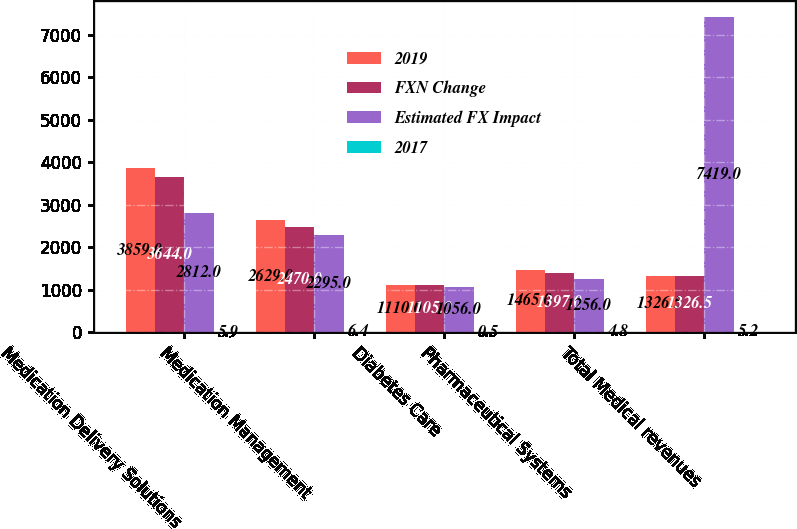Convert chart. <chart><loc_0><loc_0><loc_500><loc_500><stacked_bar_chart><ecel><fcel>Medication Delivery Solutions<fcel>Medication Management<fcel>Diabetes Care<fcel>Pharmaceutical Systems<fcel>Total Medical revenues<nl><fcel>2019<fcel>3859<fcel>2629<fcel>1110<fcel>1465<fcel>1326.5<nl><fcel>FXN Change<fcel>3644<fcel>2470<fcel>1105<fcel>1397<fcel>1326.5<nl><fcel>Estimated FX Impact<fcel>2812<fcel>2295<fcel>1056<fcel>1256<fcel>7419<nl><fcel>2017<fcel>5.9<fcel>6.4<fcel>0.5<fcel>4.8<fcel>5.2<nl></chart> 